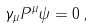<formula> <loc_0><loc_0><loc_500><loc_500>\gamma _ { \mu } P ^ { \mu } \psi = 0 \, ,</formula> 